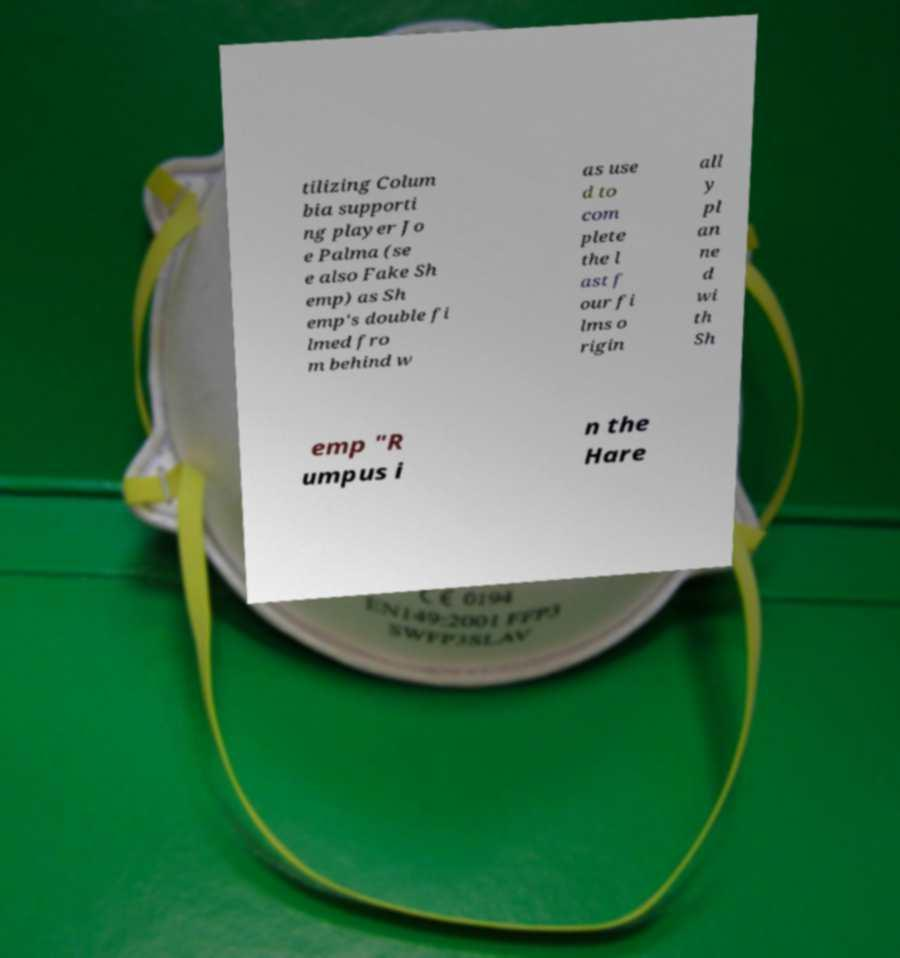Could you extract and type out the text from this image? tilizing Colum bia supporti ng player Jo e Palma (se e also Fake Sh emp) as Sh emp's double fi lmed fro m behind w as use d to com plete the l ast f our fi lms o rigin all y pl an ne d wi th Sh emp "R umpus i n the Hare 